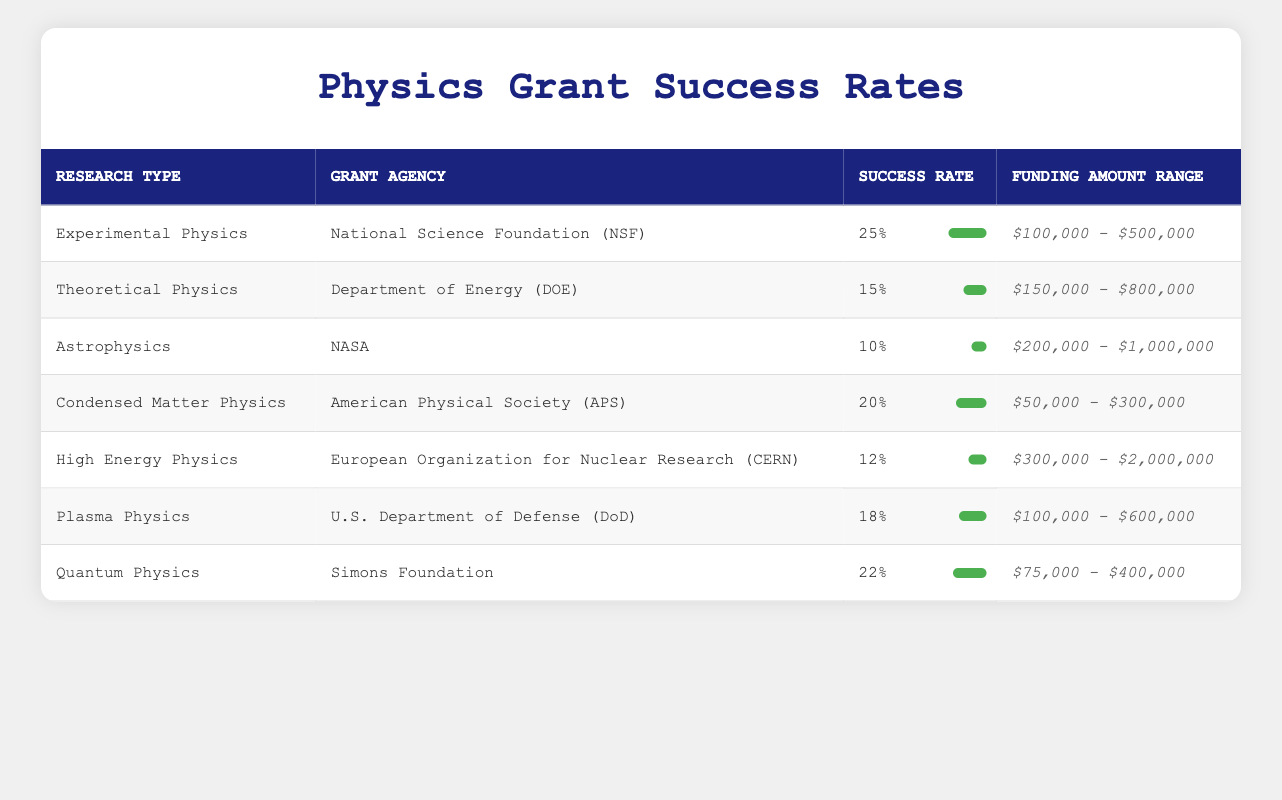What is the success rate for Experimental Physics proposals? The table lists the success rate for Experimental Physics proposals as 25%.
Answer: 25% Which grant agency has the highest success rate according to the table? From the table, the National Science Foundation (NSF) has the highest success rate of 25% for Experimental Physics.
Answer: National Science Foundation (NSF) Is the success rate for Astrophysics proposals higher than that for High Energy Physics proposals? The success rate for Astrophysics is 10%, and for High Energy Physics, it is 12%. Since 10% is less than 12%, the assertion is false.
Answer: No What is the average success rate across all types of research proposals? To calculate the average, we sum the success rates: 25% + 15% + 10% + 20% + 12% + 18% + 22% = 132%. Then divide by the number of research types (7): 132% / 7 ≈ 18.86%.
Answer: 18.86% Which research type has the widest funding amount range? The funding amount range for High Energy Physics is [$300,000, $2,000,000], which is wider compared to other categories.
Answer: High Energy Physics Are the funding ranges for Experimental Physics and Quantum Physics overlapping? The funding range for Experimental Physics is [$100,000, $500,000] and for Quantum Physics is [$75,000, $400,000]. The two ranges overlap since both range extends into the $100,000-$400,000 range.
Answer: Yes What is the difference in success rates between the highest and the lowest? The highest success rate is 25% (Experimental Physics) and the lowest is 10% (Astrophysics). The difference is 25% - 10% = 15%.
Answer: 15% If you were to categorize the grant success rates into high (greater than 20%), medium (between 15% and 20%), and low (less than 15%), how many research types fall into each category? The rates greater than 20% are Experimental Physics and Quantum Physics (2 categories), medium rates are Theoretical Physics, Plasma Physics and Condensed Matter Physics (3 categories), and low rates are Astrophysics and High Energy Physics (2 categories).
Answer: High: 2, Medium: 3, Low: 2 